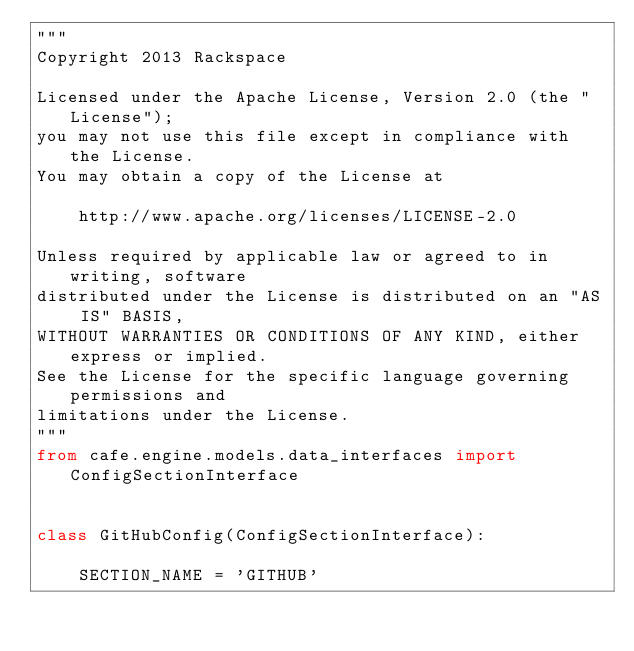Convert code to text. <code><loc_0><loc_0><loc_500><loc_500><_Python_>"""
Copyright 2013 Rackspace

Licensed under the Apache License, Version 2.0 (the "License");
you may not use this file except in compliance with the License.
You may obtain a copy of the License at

    http://www.apache.org/licenses/LICENSE-2.0

Unless required by applicable law or agreed to in writing, software
distributed under the License is distributed on an "AS IS" BASIS,
WITHOUT WARRANTIES OR CONDITIONS OF ANY KIND, either express or implied.
See the License for the specific language governing permissions and
limitations under the License.
"""
from cafe.engine.models.data_interfaces import ConfigSectionInterface


class GitHubConfig(ConfigSectionInterface):

    SECTION_NAME = 'GITHUB'
</code> 